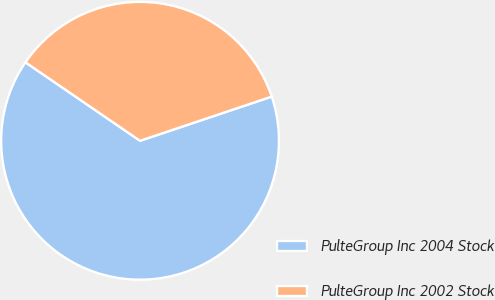Convert chart. <chart><loc_0><loc_0><loc_500><loc_500><pie_chart><fcel>PulteGroup Inc 2004 Stock<fcel>PulteGroup Inc 2002 Stock<nl><fcel>64.71%<fcel>35.29%<nl></chart> 